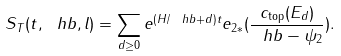Convert formula to latex. <formula><loc_0><loc_0><loc_500><loc_500>S _ { T } ( t , \ h b , l ) = \sum _ { d \geq 0 } e ^ { ( H / \ h b + d ) t } e _ { 2 * } ( \frac { c _ { \text {top} } ( E _ { d } ) } { \ h b - \psi _ { 2 } } ) .</formula> 